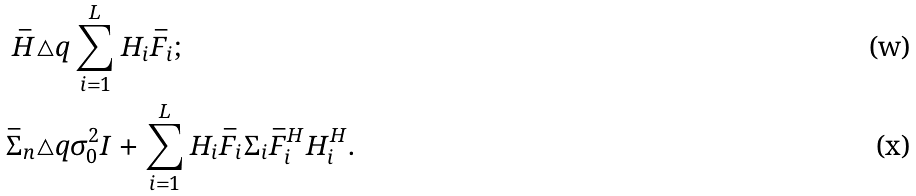<formula> <loc_0><loc_0><loc_500><loc_500>\bar { H } & \triangle q \sum _ { i = 1 } ^ { L } H _ { i } \bar { F } _ { i } ; \\ \bar { \Sigma } _ { n } & \triangle q \sigma _ { 0 } ^ { 2 } I + \sum _ { i = 1 } ^ { L } H _ { i } \bar { F } _ { i } \Sigma _ { i } \bar { F } _ { i } ^ { H } H _ { i } ^ { H } .</formula> 